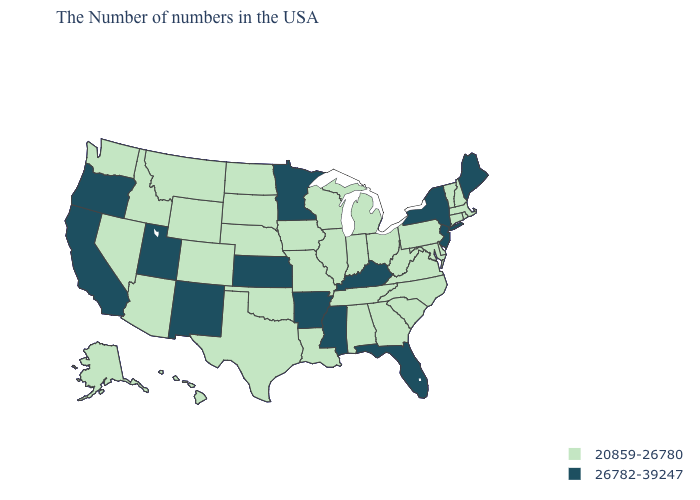What is the value of Montana?
Give a very brief answer. 20859-26780. Among the states that border Florida , which have the highest value?
Write a very short answer. Georgia, Alabama. What is the value of Wisconsin?
Quick response, please. 20859-26780. What is the value of Mississippi?
Short answer required. 26782-39247. Does Mississippi have the lowest value in the USA?
Write a very short answer. No. Name the states that have a value in the range 26782-39247?
Answer briefly. Maine, New York, New Jersey, Florida, Kentucky, Mississippi, Arkansas, Minnesota, Kansas, New Mexico, Utah, California, Oregon. Which states have the lowest value in the USA?
Short answer required. Massachusetts, Rhode Island, New Hampshire, Vermont, Connecticut, Delaware, Maryland, Pennsylvania, Virginia, North Carolina, South Carolina, West Virginia, Ohio, Georgia, Michigan, Indiana, Alabama, Tennessee, Wisconsin, Illinois, Louisiana, Missouri, Iowa, Nebraska, Oklahoma, Texas, South Dakota, North Dakota, Wyoming, Colorado, Montana, Arizona, Idaho, Nevada, Washington, Alaska, Hawaii. What is the value of New Mexico?
Quick response, please. 26782-39247. What is the value of Michigan?
Answer briefly. 20859-26780. What is the value of Ohio?
Concise answer only. 20859-26780. What is the highest value in the West ?
Quick response, please. 26782-39247. What is the value of Massachusetts?
Keep it brief. 20859-26780. Does Arkansas have the highest value in the USA?
Be succinct. Yes. Name the states that have a value in the range 26782-39247?
Keep it brief. Maine, New York, New Jersey, Florida, Kentucky, Mississippi, Arkansas, Minnesota, Kansas, New Mexico, Utah, California, Oregon. Name the states that have a value in the range 20859-26780?
Be succinct. Massachusetts, Rhode Island, New Hampshire, Vermont, Connecticut, Delaware, Maryland, Pennsylvania, Virginia, North Carolina, South Carolina, West Virginia, Ohio, Georgia, Michigan, Indiana, Alabama, Tennessee, Wisconsin, Illinois, Louisiana, Missouri, Iowa, Nebraska, Oklahoma, Texas, South Dakota, North Dakota, Wyoming, Colorado, Montana, Arizona, Idaho, Nevada, Washington, Alaska, Hawaii. 